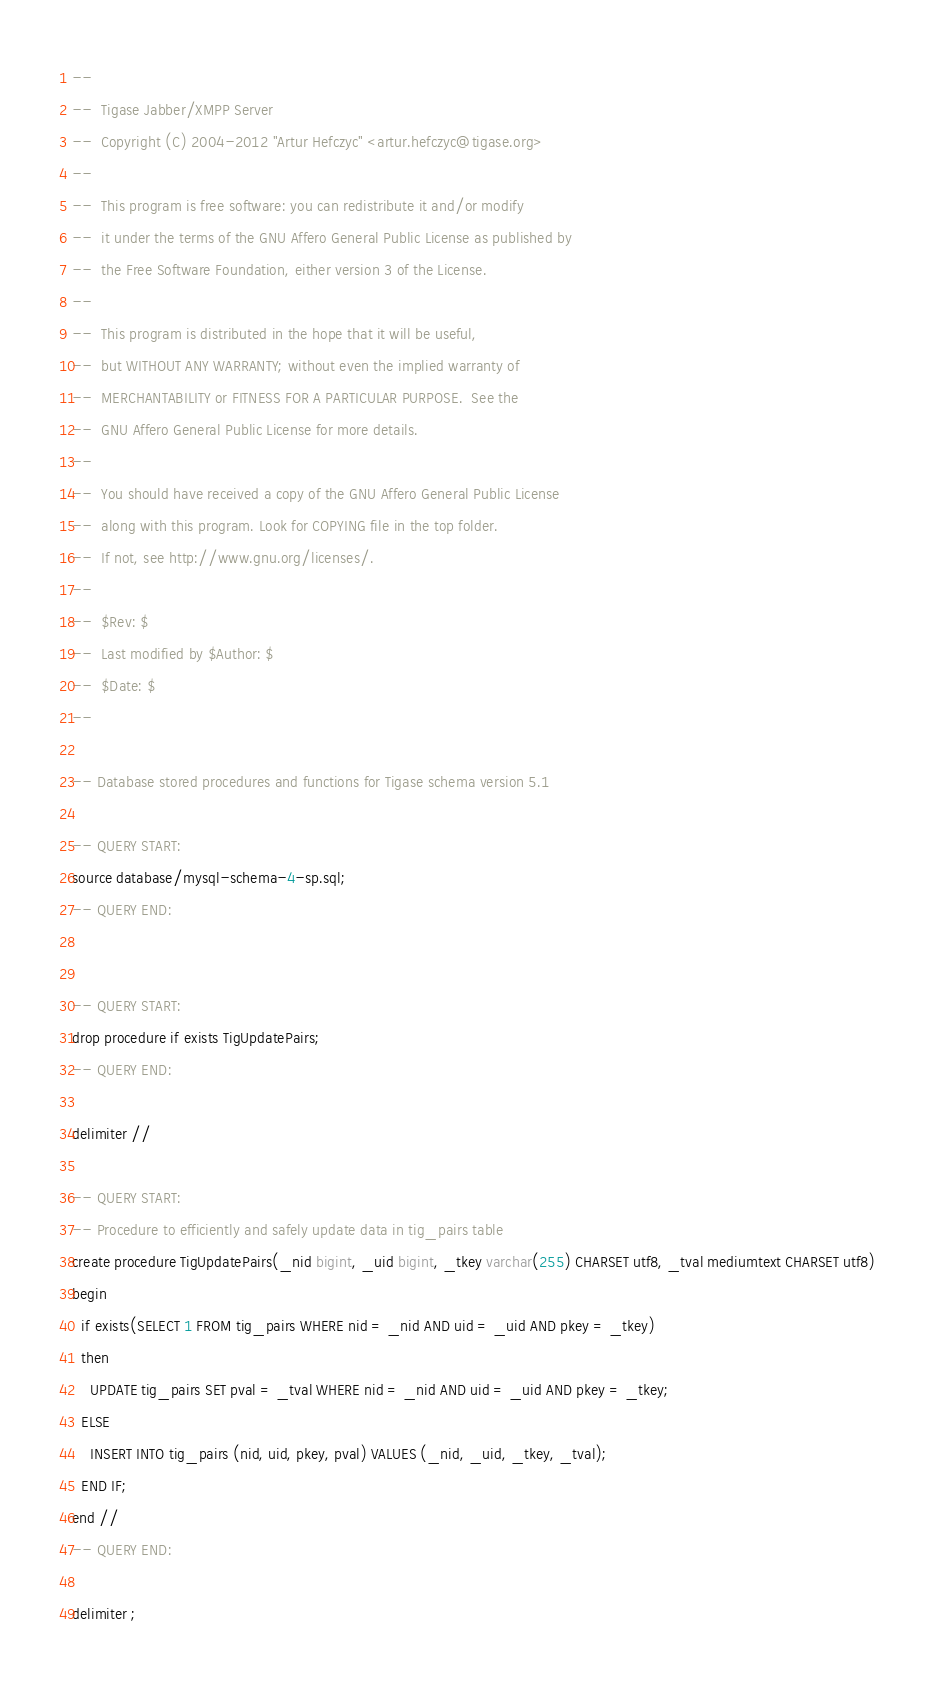Convert code to text. <code><loc_0><loc_0><loc_500><loc_500><_SQL_>--
--  Tigase Jabber/XMPP Server
--  Copyright (C) 2004-2012 "Artur Hefczyc" <artur.hefczyc@tigase.org>
--
--  This program is free software: you can redistribute it and/or modify
--  it under the terms of the GNU Affero General Public License as published by
--  the Free Software Foundation, either version 3 of the License.
--
--  This program is distributed in the hope that it will be useful,
--  but WITHOUT ANY WARRANTY; without even the implied warranty of
--  MERCHANTABILITY or FITNESS FOR A PARTICULAR PURPOSE.  See the
--  GNU Affero General Public License for more details.
--
--  You should have received a copy of the GNU Affero General Public License
--  along with this program. Look for COPYING file in the top folder.
--  If not, see http://www.gnu.org/licenses/.
--
--  $Rev: $
--  Last modified by $Author: $
--  $Date: $
--

-- Database stored procedures and functions for Tigase schema version 5.1

-- QUERY START:
source database/mysql-schema-4-sp.sql;
-- QUERY END:


-- QUERY START:
drop procedure if exists TigUpdatePairs;
-- QUERY END:
 
delimiter //

-- QUERY START:
-- Procedure to efficiently and safely update data in tig_pairs table
create procedure TigUpdatePairs(_nid bigint, _uid bigint, _tkey varchar(255) CHARSET utf8, _tval mediumtext CHARSET utf8)
begin
  if exists(SELECT 1 FROM tig_pairs WHERE nid = _nid AND uid = _uid AND pkey = _tkey)
  then
    UPDATE tig_pairs SET pval = _tval WHERE nid = _nid AND uid = _uid AND pkey = _tkey;
  ELSE
    INSERT INTO tig_pairs (nid, uid, pkey, pval) VALUES (_nid, _uid, _tkey, _tval);
  END IF;
end //
-- QUERY END:

delimiter ;
</code> 